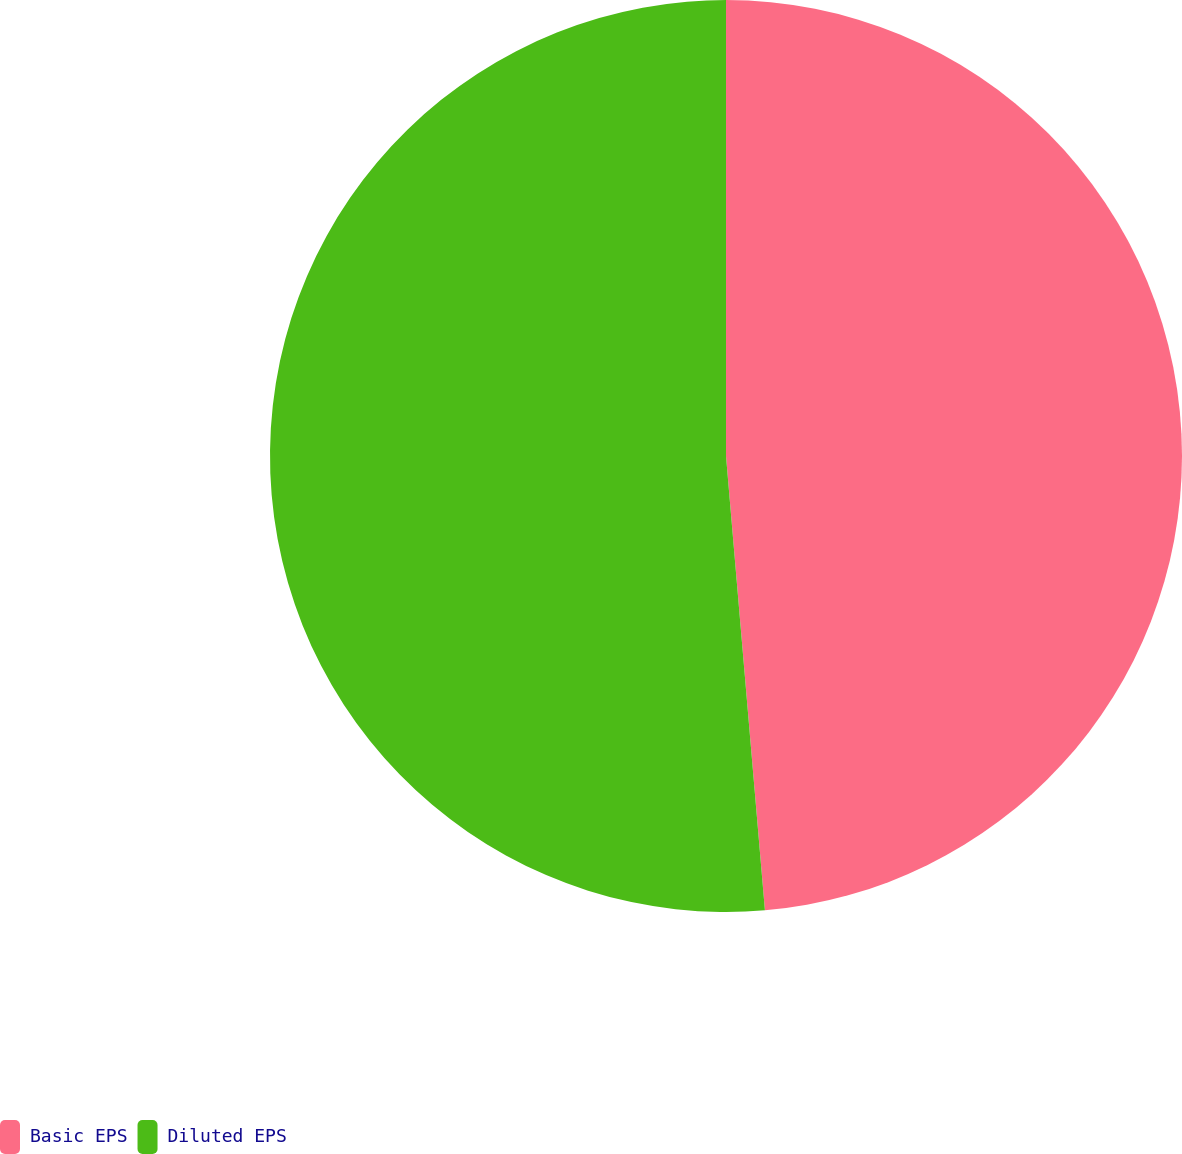Convert chart. <chart><loc_0><loc_0><loc_500><loc_500><pie_chart><fcel>Basic EPS<fcel>Diluted EPS<nl><fcel>48.64%<fcel>51.36%<nl></chart> 